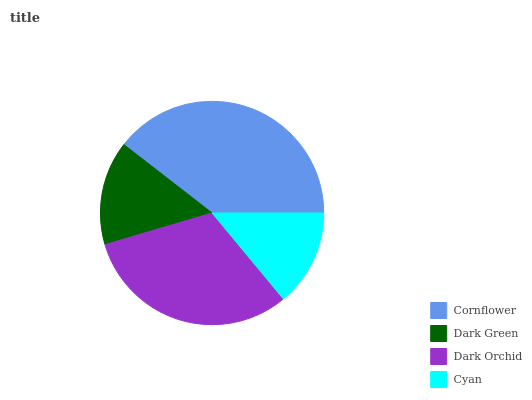Is Cyan the minimum?
Answer yes or no. Yes. Is Cornflower the maximum?
Answer yes or no. Yes. Is Dark Green the minimum?
Answer yes or no. No. Is Dark Green the maximum?
Answer yes or no. No. Is Cornflower greater than Dark Green?
Answer yes or no. Yes. Is Dark Green less than Cornflower?
Answer yes or no. Yes. Is Dark Green greater than Cornflower?
Answer yes or no. No. Is Cornflower less than Dark Green?
Answer yes or no. No. Is Dark Orchid the high median?
Answer yes or no. Yes. Is Dark Green the low median?
Answer yes or no. Yes. Is Dark Green the high median?
Answer yes or no. No. Is Cyan the low median?
Answer yes or no. No. 